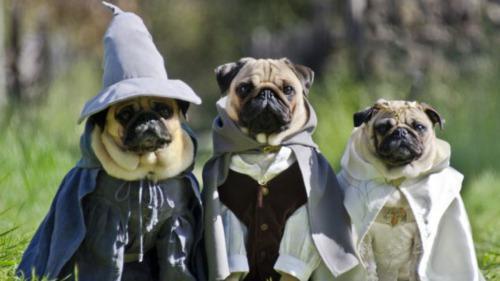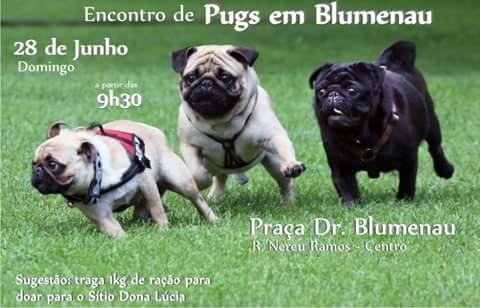The first image is the image on the left, the second image is the image on the right. For the images displayed, is the sentence "The right image contains three pug dogs." factually correct? Answer yes or no. Yes. 